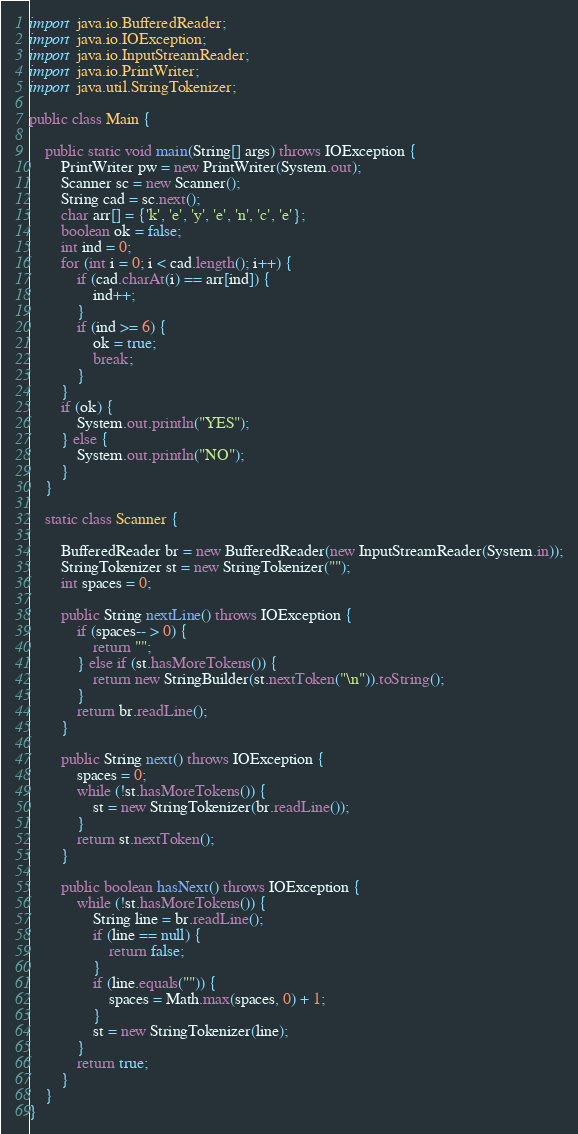Convert code to text. <code><loc_0><loc_0><loc_500><loc_500><_Java_>
import java.io.BufferedReader;
import java.io.IOException;
import java.io.InputStreamReader;
import java.io.PrintWriter;
import java.util.StringTokenizer;

public class Main {

    public static void main(String[] args) throws IOException {
        PrintWriter pw = new PrintWriter(System.out);
        Scanner sc = new Scanner();
        String cad = sc.next();
        char arr[] = {'k', 'e', 'y', 'e', 'n', 'c', 'e'};
        boolean ok = false;
        int ind = 0;
        for (int i = 0; i < cad.length(); i++) {
            if (cad.charAt(i) == arr[ind]) {
                ind++;
            }
            if (ind >= 6) {
                ok = true;
                break;
            }
        }
        if (ok) {
            System.out.println("YES");
        } else {
            System.out.println("NO");
        }
    }

    static class Scanner {

        BufferedReader br = new BufferedReader(new InputStreamReader(System.in));
        StringTokenizer st = new StringTokenizer("");
        int spaces = 0;

        public String nextLine() throws IOException {
            if (spaces-- > 0) {
                return "";
            } else if (st.hasMoreTokens()) {
                return new StringBuilder(st.nextToken("\n")).toString();
            }
            return br.readLine();
        }

        public String next() throws IOException {
            spaces = 0;
            while (!st.hasMoreTokens()) {
                st = new StringTokenizer(br.readLine());
            }
            return st.nextToken();
        }

        public boolean hasNext() throws IOException {
            while (!st.hasMoreTokens()) {
                String line = br.readLine();
                if (line == null) {
                    return false;
                }
                if (line.equals("")) {
                    spaces = Math.max(spaces, 0) + 1;
                }
                st = new StringTokenizer(line);
            }
            return true;
        }
    }
}
</code> 